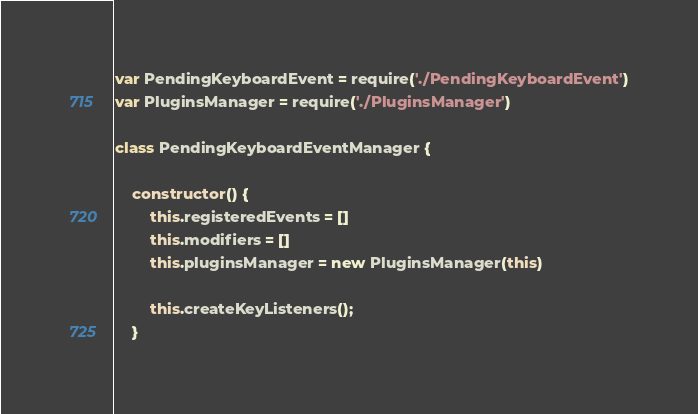Convert code to text. <code><loc_0><loc_0><loc_500><loc_500><_JavaScript_>var PendingKeyboardEvent = require('./PendingKeyboardEvent')
var PluginsManager = require('./PluginsManager')

class PendingKeyboardEventManager {

    constructor() {
        this.registeredEvents = []
        this.modifiers = []
        this.pluginsManager = new PluginsManager(this)

        this.createKeyListeners();
    }
</code> 